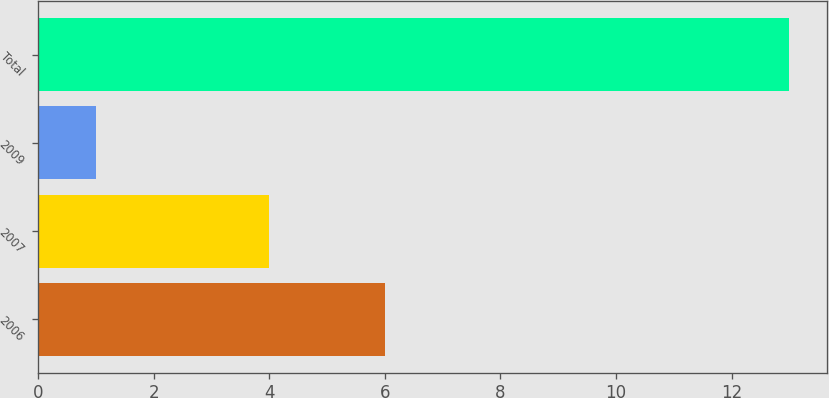Convert chart. <chart><loc_0><loc_0><loc_500><loc_500><bar_chart><fcel>2006<fcel>2007<fcel>2009<fcel>Total<nl><fcel>6<fcel>4<fcel>1<fcel>13<nl></chart> 